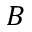Convert formula to latex. <formula><loc_0><loc_0><loc_500><loc_500>B</formula> 